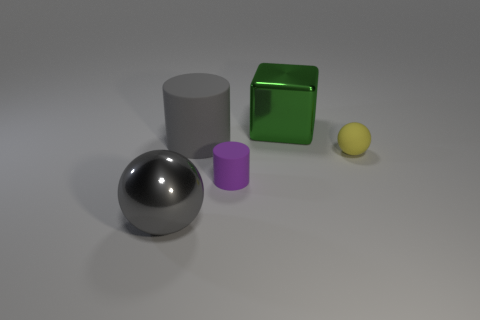Add 1 small blue matte cubes. How many objects exist? 6 Subtract all gray cylinders. How many cylinders are left? 1 Subtract all cyan balls. How many gray cylinders are left? 1 Subtract all cubes. How many objects are left? 4 Subtract 2 spheres. How many spheres are left? 0 Add 2 big rubber cylinders. How many big rubber cylinders are left? 3 Add 3 large cylinders. How many large cylinders exist? 4 Subtract 0 green cylinders. How many objects are left? 5 Subtract all cyan spheres. Subtract all blue cylinders. How many spheres are left? 2 Subtract all big red rubber cylinders. Subtract all tiny things. How many objects are left? 3 